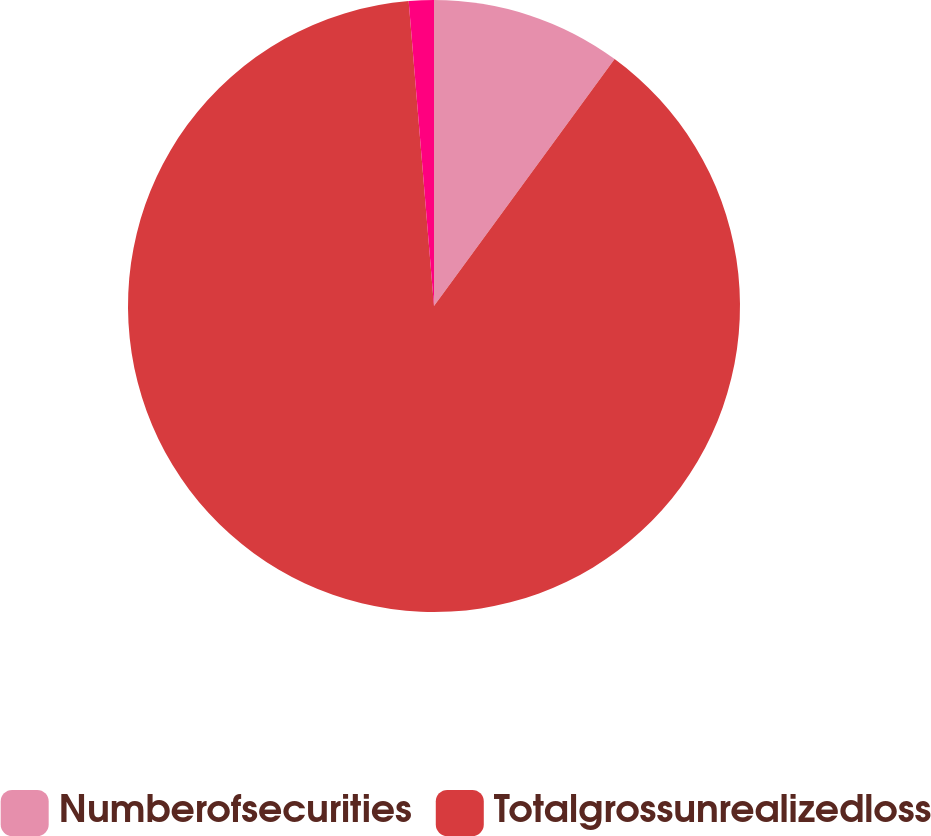<chart> <loc_0><loc_0><loc_500><loc_500><pie_chart><fcel>Numberofsecurities<fcel>Totalgrossunrealizedloss<fcel>Unnamed: 2<nl><fcel>10.05%<fcel>88.63%<fcel>1.32%<nl></chart> 